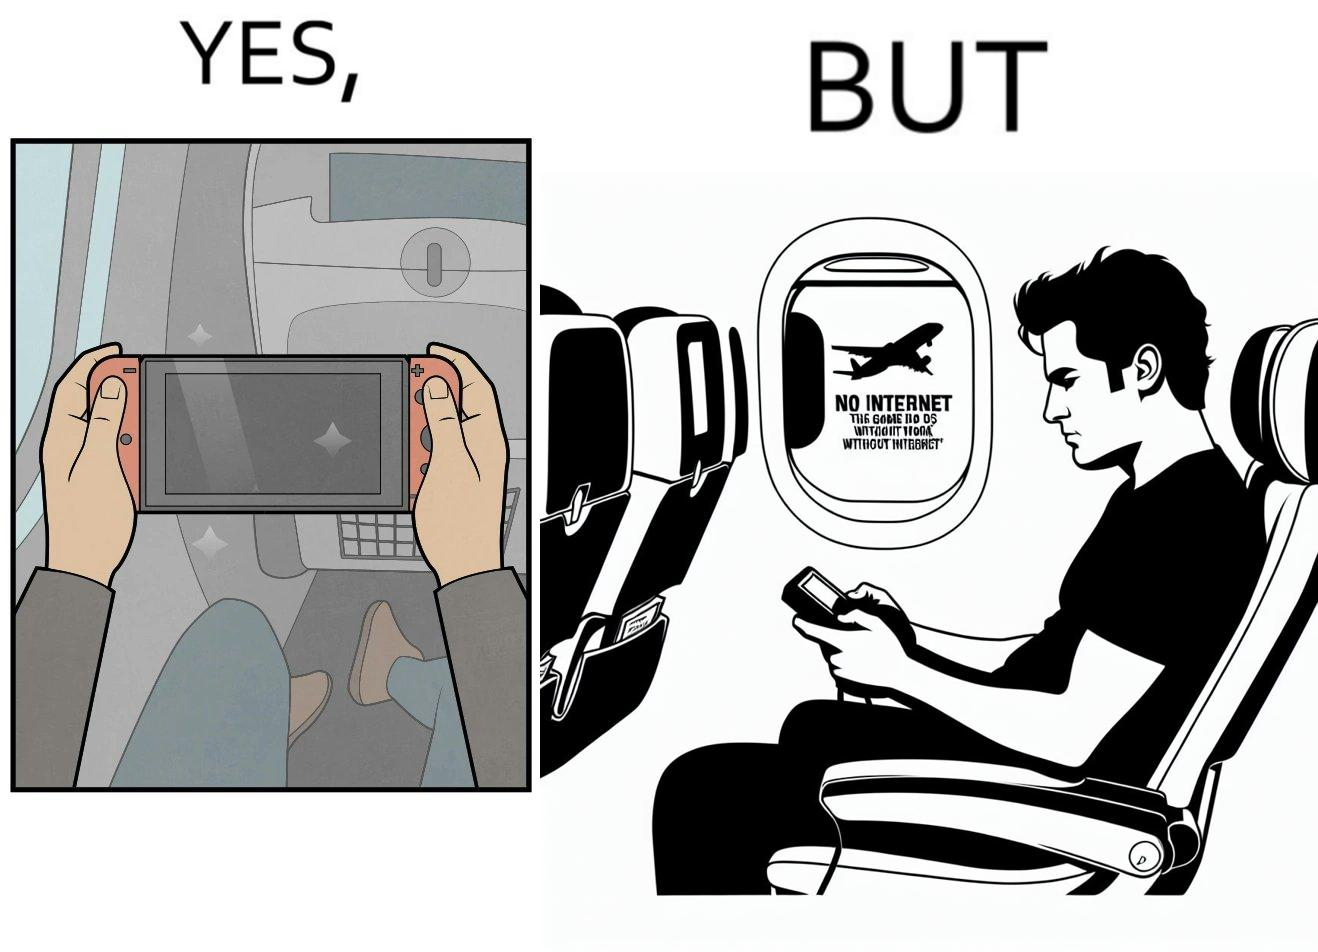Describe what you see in the left and right parts of this image. In the left part of the image: a person sitting in a flight seat, with a gaming console in the person's hands. In the right part of the image: a person sitting in a flight seat, with a gaming console in the person's hands, with a message which shows "No Internet, the game does not work without internet". 